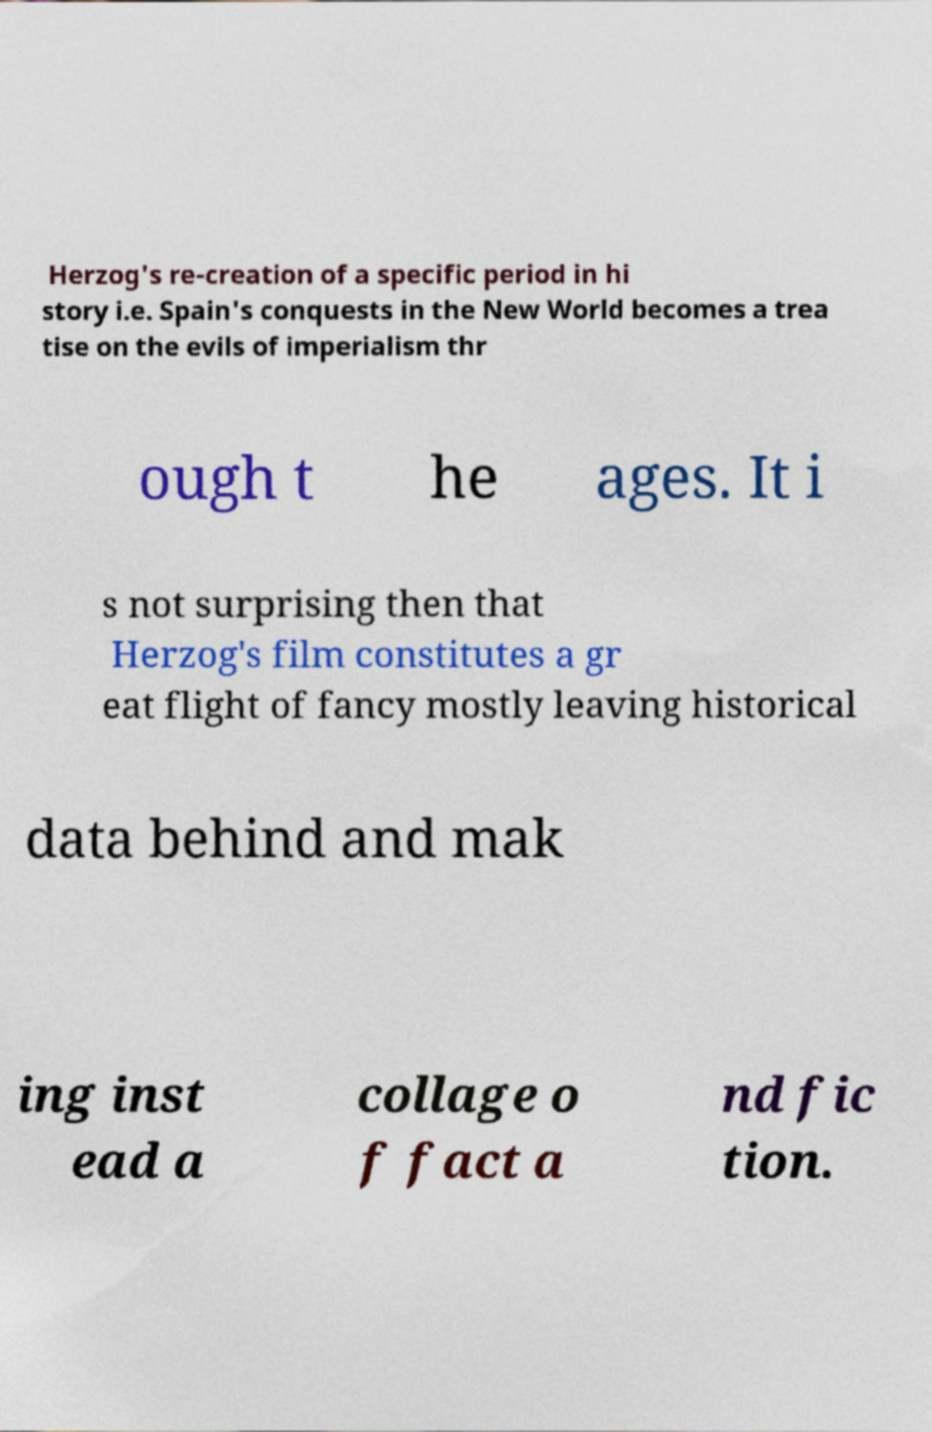Can you read and provide the text displayed in the image?This photo seems to have some interesting text. Can you extract and type it out for me? Herzog's re-creation of a specific period in hi story i.e. Spain's conquests in the New World becomes a trea tise on the evils of imperialism thr ough t he ages. It i s not surprising then that Herzog's film constitutes a gr eat flight of fancy mostly leaving historical data behind and mak ing inst ead a collage o f fact a nd fic tion. 